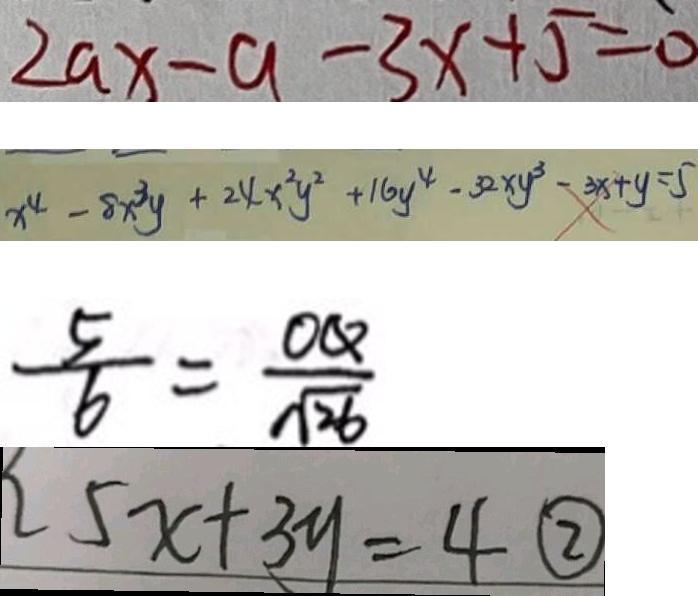Convert formula to latex. <formula><loc_0><loc_0><loc_500><loc_500>2 a x - a - 3 x + 5 = 0 
 x ^ { 4 } - 8 x ^ { 3 } y + 2 4 x ^ { 2 } y ^ { 2 } + 1 6 y ^ { 4 } - 3 2 x y ^ { 3 } - 3 x + y = 5 
 \frac { 5 } { 6 } = \frac { O Q } { \sqrt { 2 6 } } 
 5 x + 3 y = 4 \textcircled { 2 }</formula> 